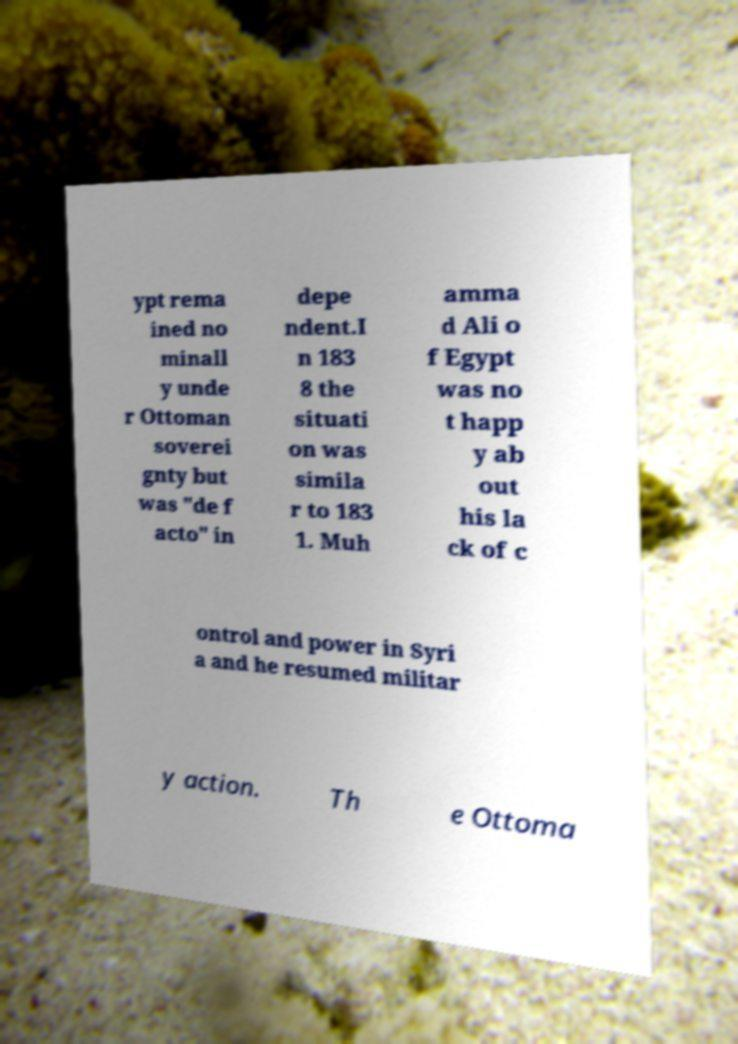Can you read and provide the text displayed in the image?This photo seems to have some interesting text. Can you extract and type it out for me? ypt rema ined no minall y unde r Ottoman soverei gnty but was "de f acto" in depe ndent.I n 183 8 the situati on was simila r to 183 1. Muh amma d Ali o f Egypt was no t happ y ab out his la ck of c ontrol and power in Syri a and he resumed militar y action. Th e Ottoma 